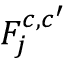Convert formula to latex. <formula><loc_0><loc_0><loc_500><loc_500>F _ { j } ^ { c , c ^ { \prime } }</formula> 